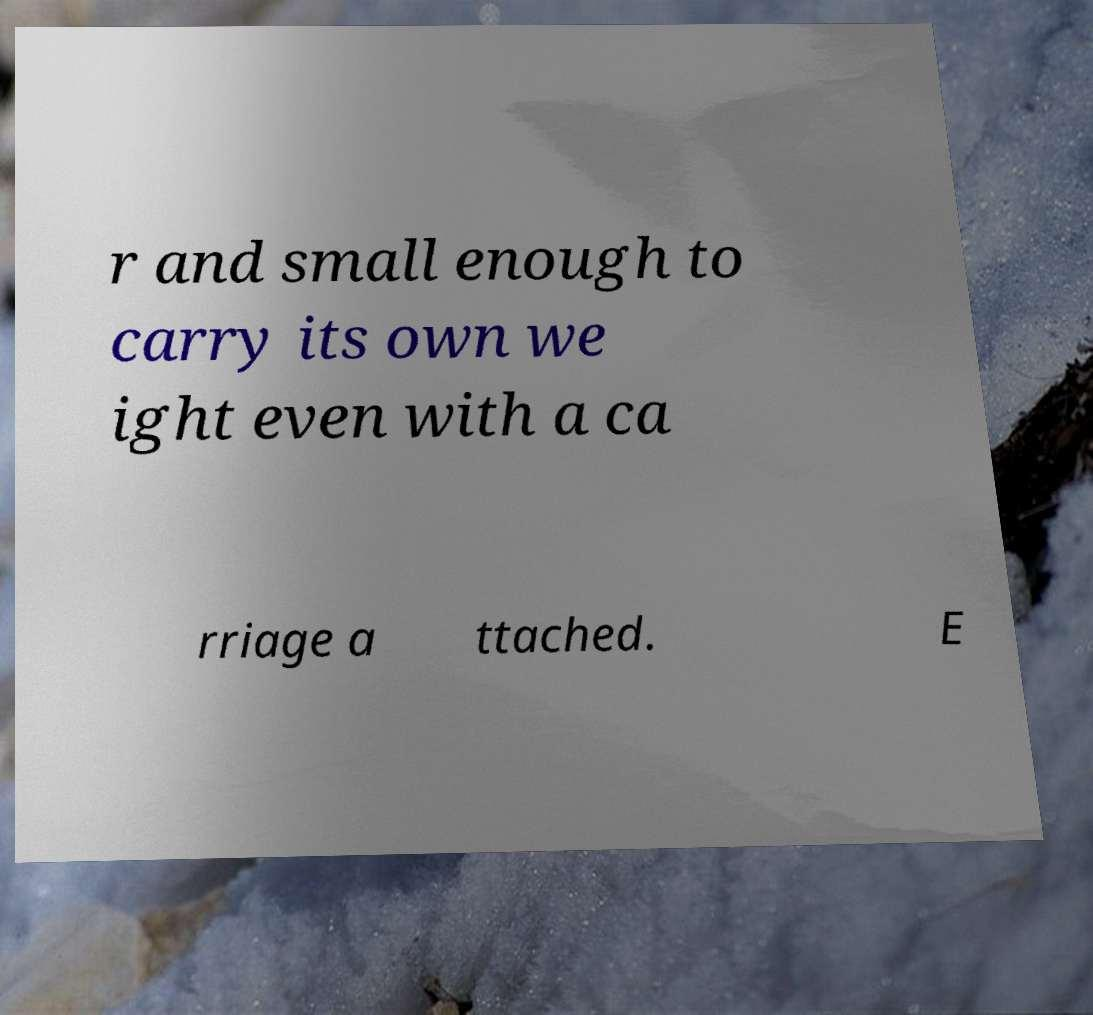For documentation purposes, I need the text within this image transcribed. Could you provide that? r and small enough to carry its own we ight even with a ca rriage a ttached. E 